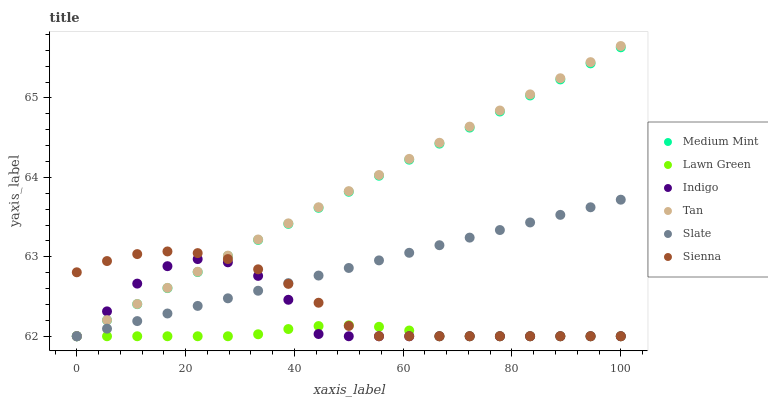Does Lawn Green have the minimum area under the curve?
Answer yes or no. Yes. Does Tan have the maximum area under the curve?
Answer yes or no. Yes. Does Indigo have the minimum area under the curve?
Answer yes or no. No. Does Indigo have the maximum area under the curve?
Answer yes or no. No. Is Tan the smoothest?
Answer yes or no. Yes. Is Indigo the roughest?
Answer yes or no. Yes. Is Lawn Green the smoothest?
Answer yes or no. No. Is Lawn Green the roughest?
Answer yes or no. No. Does Medium Mint have the lowest value?
Answer yes or no. Yes. Does Tan have the highest value?
Answer yes or no. Yes. Does Indigo have the highest value?
Answer yes or no. No. Does Indigo intersect Tan?
Answer yes or no. Yes. Is Indigo less than Tan?
Answer yes or no. No. Is Indigo greater than Tan?
Answer yes or no. No. 